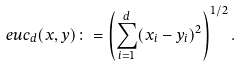<formula> <loc_0><loc_0><loc_500><loc_500>\ e u c _ { d } ( x , y ) \colon = \left ( \sum _ { i = 1 } ^ { d } ( x _ { i } - y _ { i } ) ^ { 2 } \right ) ^ { 1 / 2 } .</formula> 